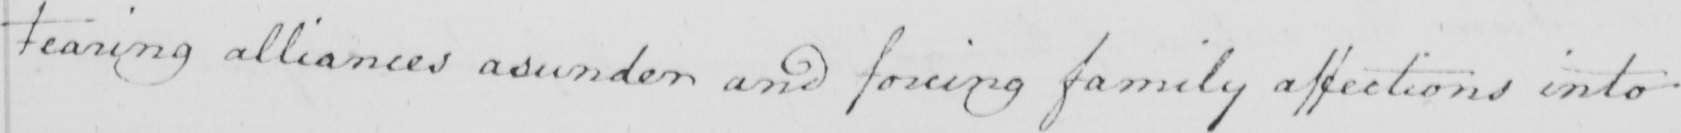Can you tell me what this handwritten text says? Tearing alliances asunder and foreign family affections into 